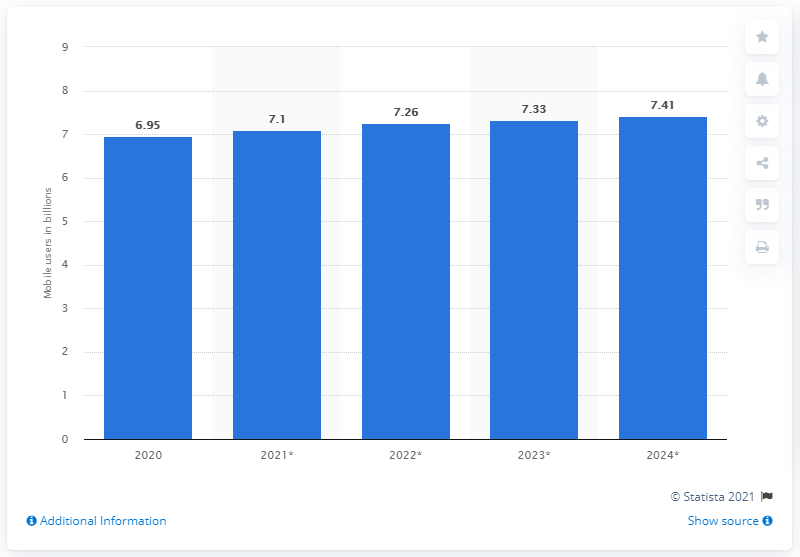Indicate a few pertinent items in this graphic. By 2024, it is projected that there will be approximately 7.41 billion mobile users worldwide. The number of mobile users in 2020 was 0.46 greater than in 2024. In 2020, there were approximately 7 billion mobile users worldwide. The year with the lowest number of mobile users in billions was 2020. 